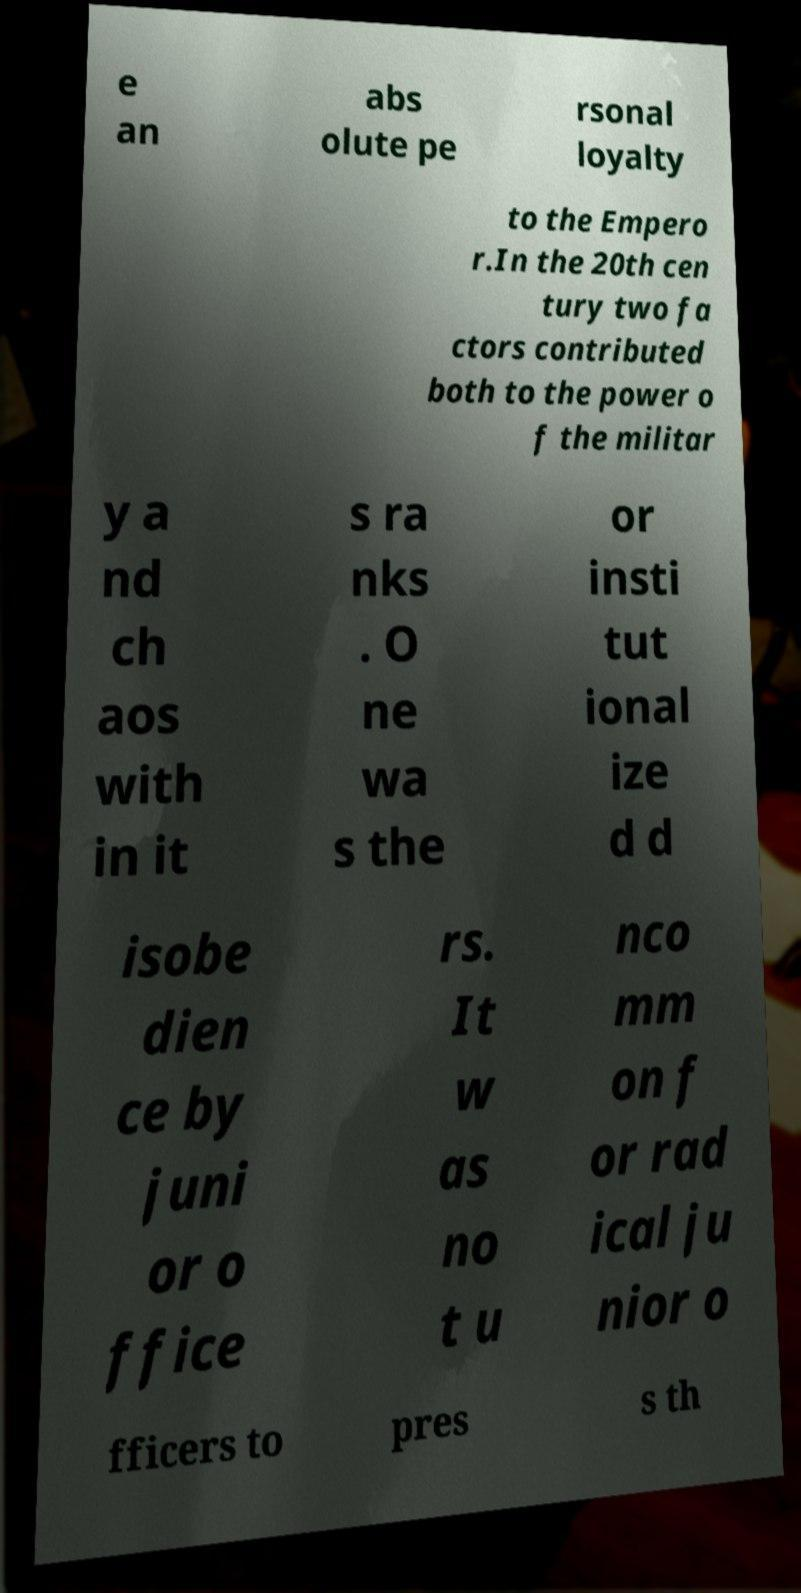Can you accurately transcribe the text from the provided image for me? e an abs olute pe rsonal loyalty to the Empero r.In the 20th cen tury two fa ctors contributed both to the power o f the militar y a nd ch aos with in it s ra nks . O ne wa s the or insti tut ional ize d d isobe dien ce by juni or o ffice rs. It w as no t u nco mm on f or rad ical ju nior o fficers to pres s th 